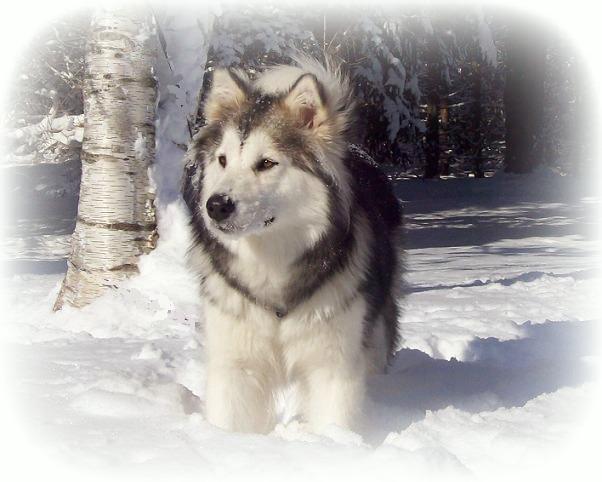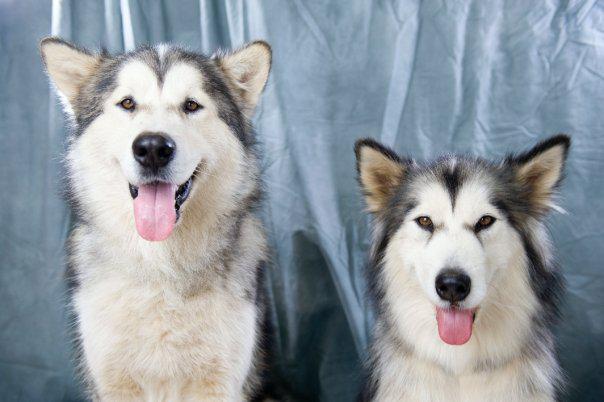The first image is the image on the left, the second image is the image on the right. Evaluate the accuracy of this statement regarding the images: "The left image features one non-reclining dog with snow on its face, and the right image includes at least one forward-facing dog with its tongue hanging down.". Is it true? Answer yes or no. Yes. The first image is the image on the left, the second image is the image on the right. Given the left and right images, does the statement "There are exactly two dogs posing in a snowy environment." hold true? Answer yes or no. No. 